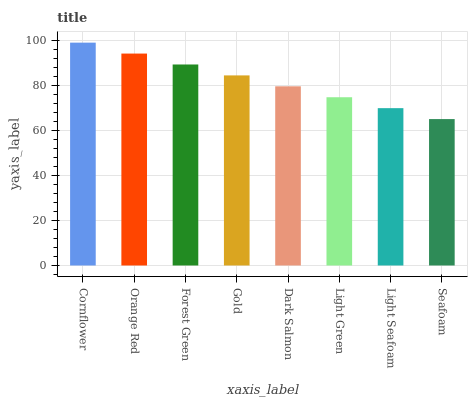Is Orange Red the minimum?
Answer yes or no. No. Is Orange Red the maximum?
Answer yes or no. No. Is Cornflower greater than Orange Red?
Answer yes or no. Yes. Is Orange Red less than Cornflower?
Answer yes or no. Yes. Is Orange Red greater than Cornflower?
Answer yes or no. No. Is Cornflower less than Orange Red?
Answer yes or no. No. Is Gold the high median?
Answer yes or no. Yes. Is Dark Salmon the low median?
Answer yes or no. Yes. Is Light Green the high median?
Answer yes or no. No. Is Light Green the low median?
Answer yes or no. No. 